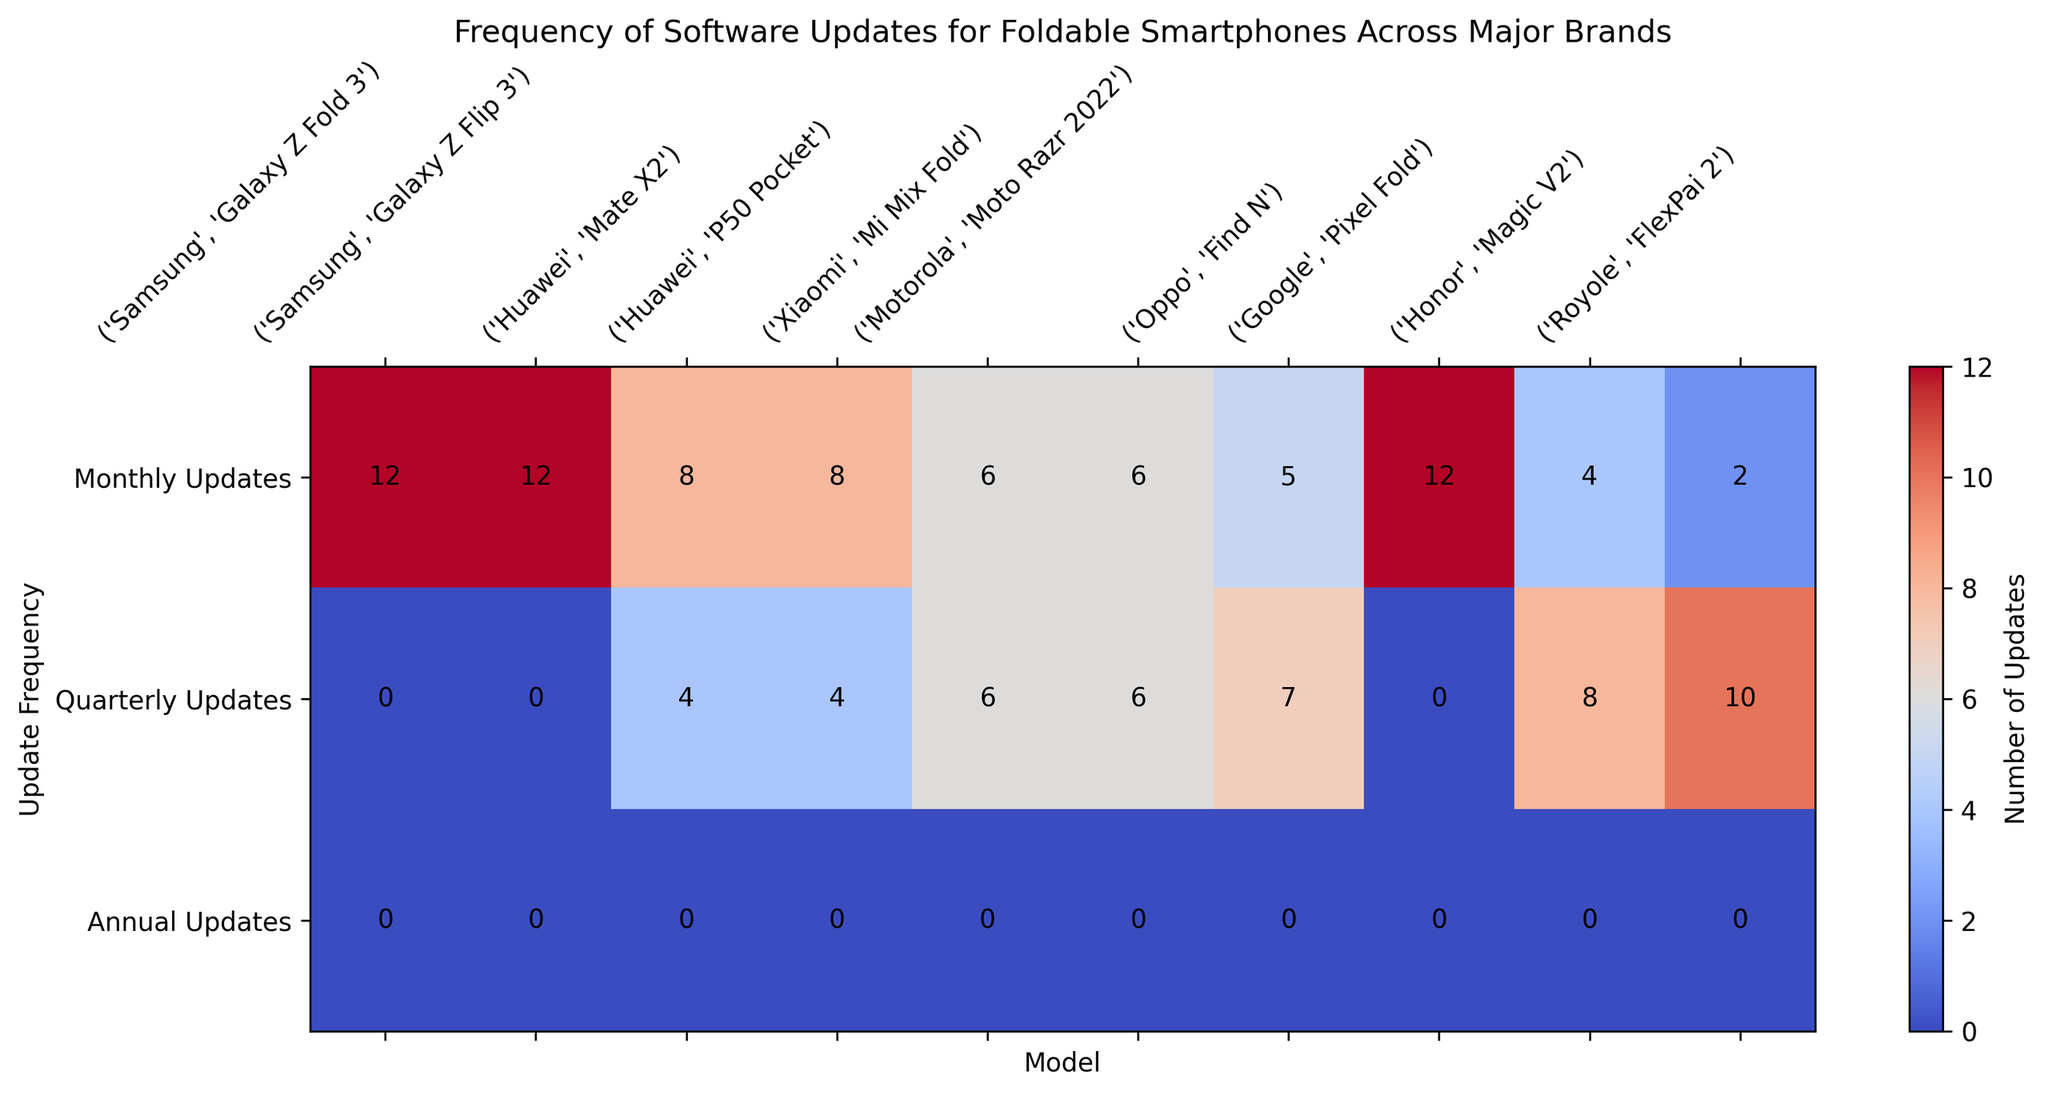Which brand has the most models receiving monthly updates? Look at the heatmap and count the number of models for each brand that receive monthly updates. Samsung and Google have models with 12 updates, the highest frequency. As Samsung has two models and Google has one, Samsung is the brand with the most models receiving monthly updates.
Answer: Samsung Which model receives the highest number of quarterly updates? Observe the quarterly updates row in the heatmap and identify the model with the highest value, which is 10 quarterly updates for the Royole FlexPai 2.
Answer: Royole FlexPai 2 Which model(s) receive exactly 8 quarterly updates? Check the heatmap and identify the models corresponding to the value of 8 in the quarterly updates row, which are the Huawei Mate X2, Huawei P50 Pocket, and Honor Magic V2.
Answer: Huawei Mate X2, Huawei P50 Pocket, Honor Magic V2 How many models receive more than 6 monthly updates? Look at the monthly updates row and count the number of models that receive updates greater than 6. The models include the Samsung Galaxy Z Fold 3, Samsung Galaxy Z Flip 3, Google Pixel Fold, Huawei Mate X2, and Huawei P50 Pocket, comprising a total of 6 models.
Answer: 6 Which brand provides the widest range of update frequencies (monthly, quarterly, and annually)? Compare the number of distinct update frequencies (monthly, quarterly, annual) per brand in the heatmap. Brands like Xiaomi, Motorola, and Oppo show updates across both monthly and quarterly, but not annually. Since Royole provides monthly and quarterly frequencies, it also does not provide annual updates, thus none offer the widest range.
Answer: None Which brands give quarterly updates to more than one model? Check the quarterly updates row and list the brands with more than one model receiving quarterly updates. Huawei and Xiaomi meet this criterion.
Answer: Huawei, Xiaomi Which brand has the fewest models receiving monthly updates? Find the brands with models listed under monthly updates and identify the brand with the lowest count, which is Royole with only one model, the FlexPai 2.
Answer: Royole What is the total number of annual updates received by all models across all brands? Sum all the values in the annual updates row from the heatmap. Since every model receives 0 annual updates, the total is 0.
Answer: 0 How many models receive exactly 6 monthly updates? Count the number of models in the monthly updates row with exactly 6 updates, corresponding to Xiaomi Mi Mix Fold and Motorola Moto Razr 2022.
Answer: 2 Which model receives the fewest number of monthly updates? Identify the minimum value in the monthly updates row and the corresponding model, which is Royole FlexPai 2 receiving 2 monthly updates.
Answer: Royole FlexPai 2 